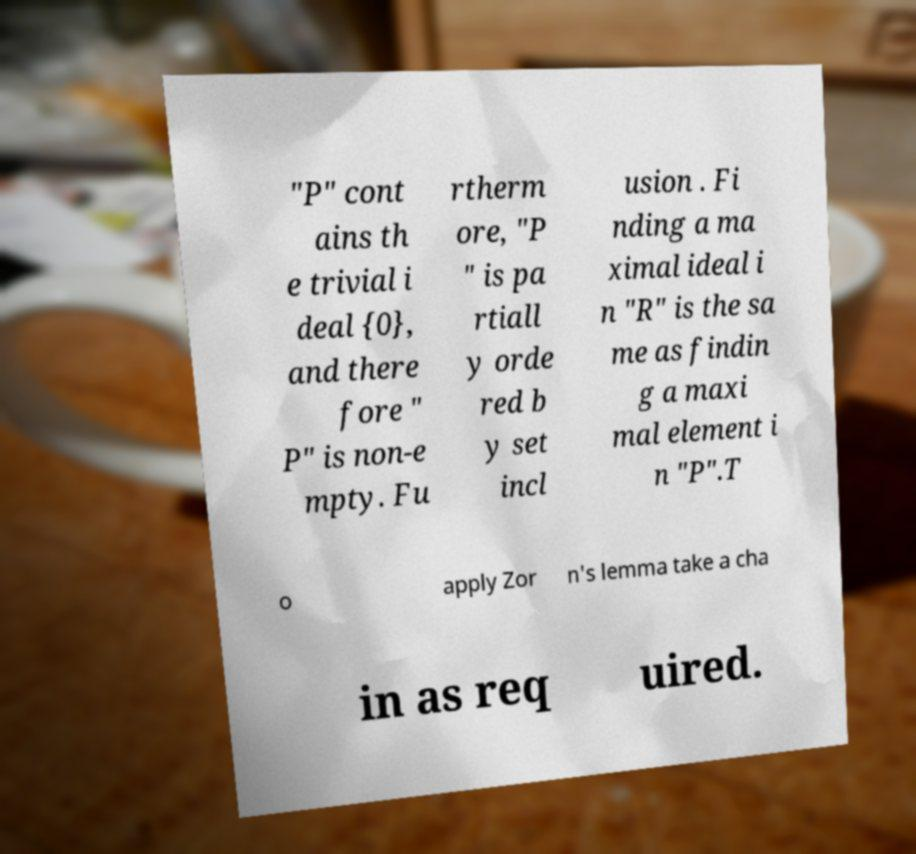I need the written content from this picture converted into text. Can you do that? "P" cont ains th e trivial i deal {0}, and there fore " P" is non-e mpty. Fu rtherm ore, "P " is pa rtiall y orde red b y set incl usion . Fi nding a ma ximal ideal i n "R" is the sa me as findin g a maxi mal element i n "P".T o apply Zor n's lemma take a cha in as req uired. 